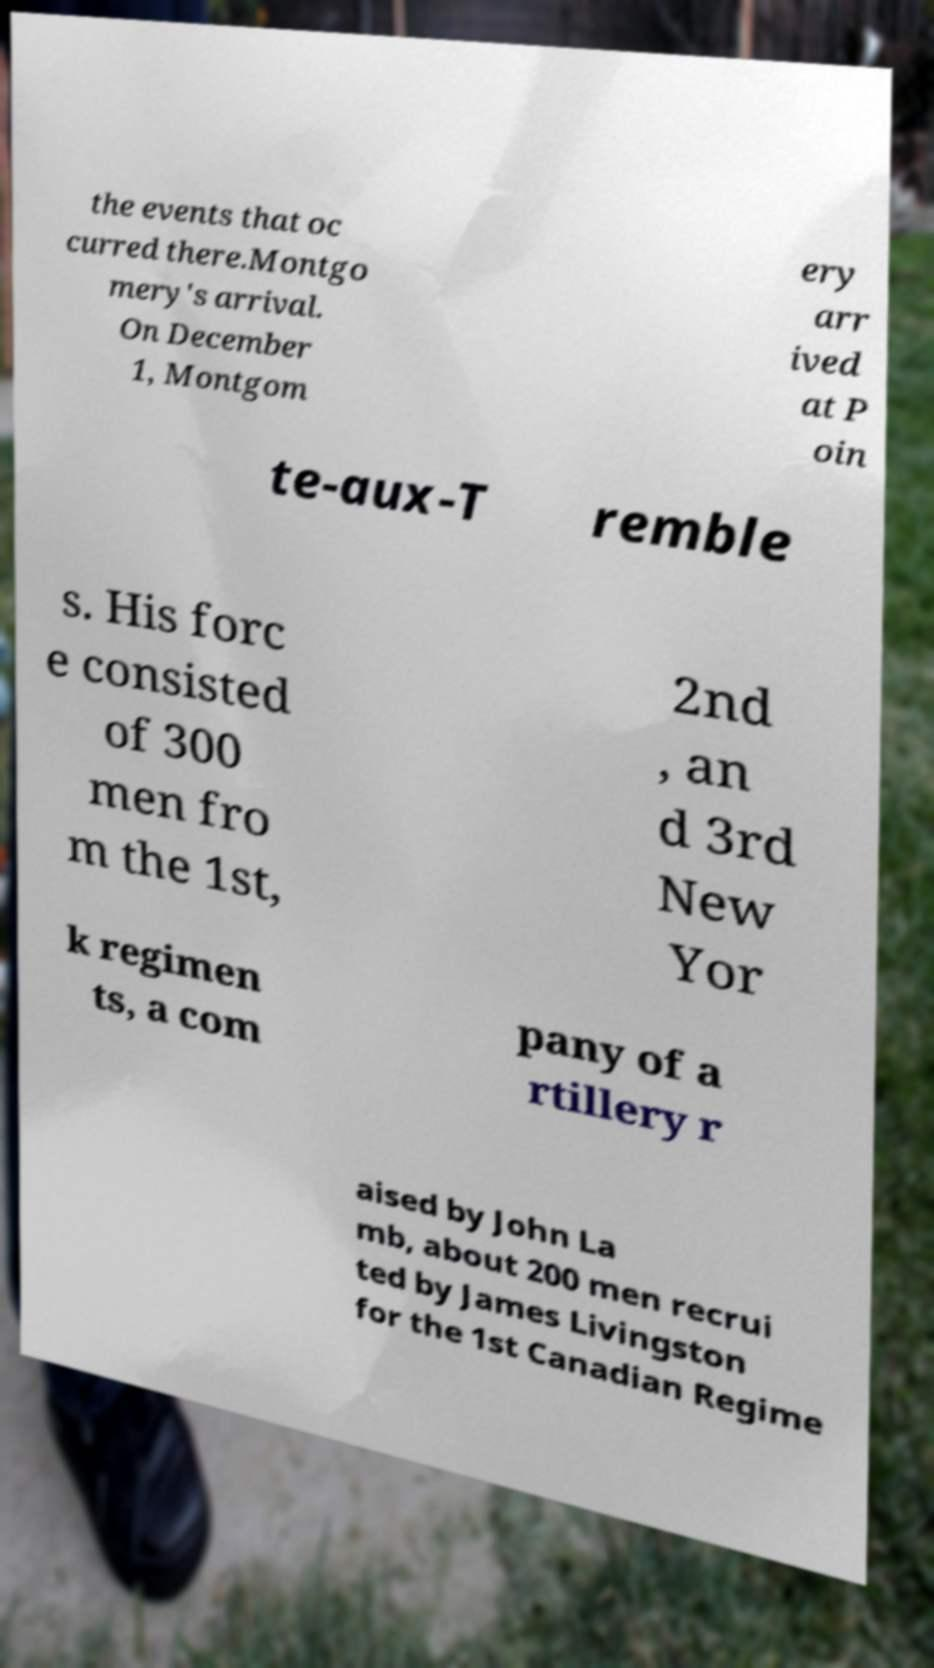Can you read and provide the text displayed in the image?This photo seems to have some interesting text. Can you extract and type it out for me? the events that oc curred there.Montgo mery's arrival. On December 1, Montgom ery arr ived at P oin te-aux-T remble s. His forc e consisted of 300 men fro m the 1st, 2nd , an d 3rd New Yor k regimen ts, a com pany of a rtillery r aised by John La mb, about 200 men recrui ted by James Livingston for the 1st Canadian Regime 